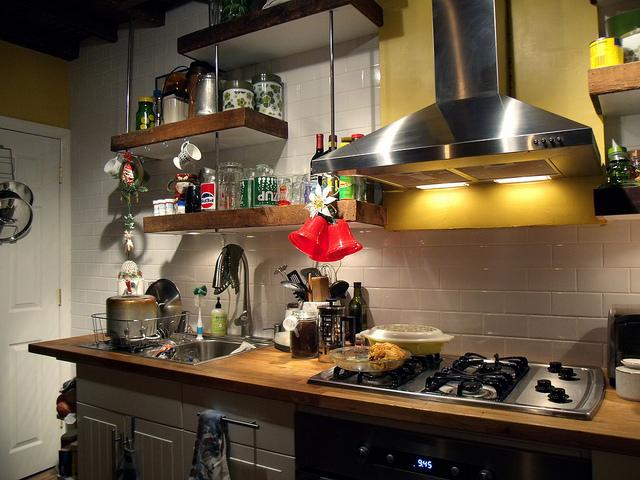Is the person using this kitchen organized?
Give a very brief answer. Yes. What time is in this photo?
Short answer required. 9:45. Is this a gas cooktop?
Write a very short answer. Yes. 